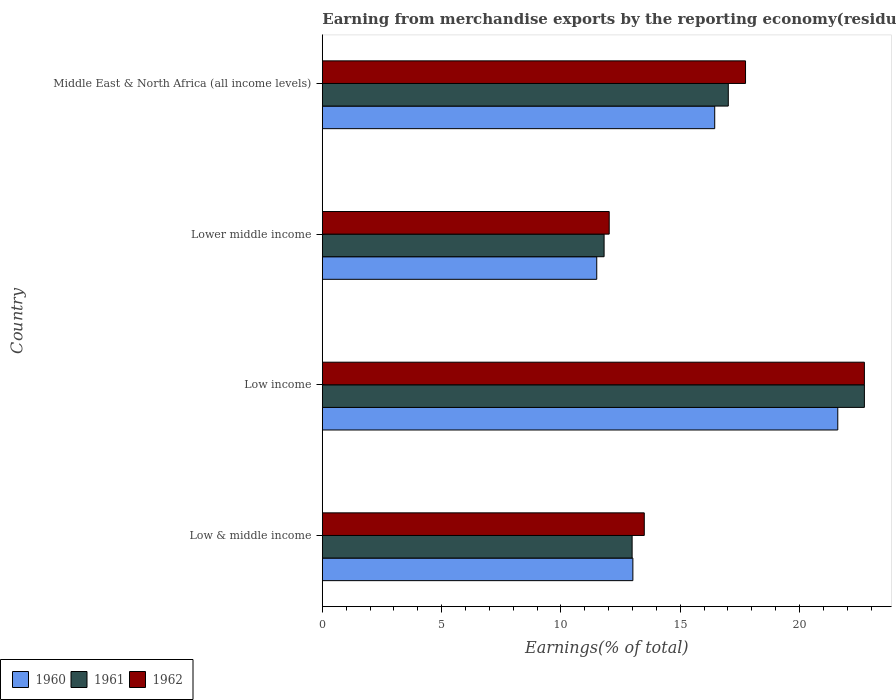How many different coloured bars are there?
Offer a terse response. 3. How many groups of bars are there?
Offer a very short reply. 4. Are the number of bars on each tick of the Y-axis equal?
Ensure brevity in your answer.  Yes. How many bars are there on the 2nd tick from the top?
Give a very brief answer. 3. How many bars are there on the 3rd tick from the bottom?
Your answer should be very brief. 3. What is the label of the 2nd group of bars from the top?
Provide a succinct answer. Lower middle income. What is the percentage of amount earned from merchandise exports in 1962 in Low income?
Provide a succinct answer. 22.72. Across all countries, what is the maximum percentage of amount earned from merchandise exports in 1960?
Make the answer very short. 21.61. Across all countries, what is the minimum percentage of amount earned from merchandise exports in 1961?
Your answer should be compact. 11.81. In which country was the percentage of amount earned from merchandise exports in 1962 maximum?
Keep it short and to the point. Low income. In which country was the percentage of amount earned from merchandise exports in 1962 minimum?
Offer a very short reply. Lower middle income. What is the total percentage of amount earned from merchandise exports in 1961 in the graph?
Offer a terse response. 64.53. What is the difference between the percentage of amount earned from merchandise exports in 1962 in Low & middle income and that in Lower middle income?
Ensure brevity in your answer.  1.47. What is the difference between the percentage of amount earned from merchandise exports in 1961 in Low & middle income and the percentage of amount earned from merchandise exports in 1960 in Middle East & North Africa (all income levels)?
Make the answer very short. -3.46. What is the average percentage of amount earned from merchandise exports in 1962 per country?
Your answer should be very brief. 16.49. What is the difference between the percentage of amount earned from merchandise exports in 1962 and percentage of amount earned from merchandise exports in 1960 in Low & middle income?
Your answer should be compact. 0.48. What is the ratio of the percentage of amount earned from merchandise exports in 1960 in Low & middle income to that in Middle East & North Africa (all income levels)?
Your answer should be very brief. 0.79. Is the difference between the percentage of amount earned from merchandise exports in 1962 in Low income and Middle East & North Africa (all income levels) greater than the difference between the percentage of amount earned from merchandise exports in 1960 in Low income and Middle East & North Africa (all income levels)?
Offer a terse response. No. What is the difference between the highest and the second highest percentage of amount earned from merchandise exports in 1961?
Keep it short and to the point. 5.7. What is the difference between the highest and the lowest percentage of amount earned from merchandise exports in 1961?
Give a very brief answer. 10.91. How many bars are there?
Your answer should be compact. 12. Are all the bars in the graph horizontal?
Make the answer very short. Yes. How many countries are there in the graph?
Provide a short and direct response. 4. What is the difference between two consecutive major ticks on the X-axis?
Ensure brevity in your answer.  5. Are the values on the major ticks of X-axis written in scientific E-notation?
Provide a succinct answer. No. Does the graph contain any zero values?
Offer a very short reply. No. Where does the legend appear in the graph?
Your answer should be very brief. Bottom left. How are the legend labels stacked?
Ensure brevity in your answer.  Horizontal. What is the title of the graph?
Your response must be concise. Earning from merchandise exports by the reporting economy(residual) of countries. Does "1997" appear as one of the legend labels in the graph?
Your response must be concise. No. What is the label or title of the X-axis?
Provide a short and direct response. Earnings(% of total). What is the Earnings(% of total) in 1960 in Low & middle income?
Provide a succinct answer. 13.02. What is the Earnings(% of total) in 1961 in Low & middle income?
Ensure brevity in your answer.  12.99. What is the Earnings(% of total) in 1962 in Low & middle income?
Provide a short and direct response. 13.49. What is the Earnings(% of total) in 1960 in Low income?
Your answer should be very brief. 21.61. What is the Earnings(% of total) in 1961 in Low income?
Give a very brief answer. 22.72. What is the Earnings(% of total) of 1962 in Low income?
Make the answer very short. 22.72. What is the Earnings(% of total) of 1960 in Lower middle income?
Keep it short and to the point. 11.5. What is the Earnings(% of total) in 1961 in Lower middle income?
Provide a succinct answer. 11.81. What is the Earnings(% of total) of 1962 in Lower middle income?
Provide a succinct answer. 12.02. What is the Earnings(% of total) of 1960 in Middle East & North Africa (all income levels)?
Offer a very short reply. 16.45. What is the Earnings(% of total) in 1961 in Middle East & North Africa (all income levels)?
Provide a succinct answer. 17.02. What is the Earnings(% of total) in 1962 in Middle East & North Africa (all income levels)?
Offer a very short reply. 17.74. Across all countries, what is the maximum Earnings(% of total) in 1960?
Your answer should be very brief. 21.61. Across all countries, what is the maximum Earnings(% of total) in 1961?
Provide a succinct answer. 22.72. Across all countries, what is the maximum Earnings(% of total) of 1962?
Make the answer very short. 22.72. Across all countries, what is the minimum Earnings(% of total) in 1960?
Your answer should be compact. 11.5. Across all countries, what is the minimum Earnings(% of total) of 1961?
Offer a terse response. 11.81. Across all countries, what is the minimum Earnings(% of total) of 1962?
Give a very brief answer. 12.02. What is the total Earnings(% of total) of 1960 in the graph?
Your answer should be compact. 62.57. What is the total Earnings(% of total) of 1961 in the graph?
Provide a succinct answer. 64.53. What is the total Earnings(% of total) of 1962 in the graph?
Your answer should be compact. 65.98. What is the difference between the Earnings(% of total) in 1960 in Low & middle income and that in Low income?
Your answer should be very brief. -8.59. What is the difference between the Earnings(% of total) in 1961 in Low & middle income and that in Low income?
Keep it short and to the point. -9.74. What is the difference between the Earnings(% of total) of 1962 in Low & middle income and that in Low income?
Offer a very short reply. -9.23. What is the difference between the Earnings(% of total) of 1960 in Low & middle income and that in Lower middle income?
Your answer should be very brief. 1.51. What is the difference between the Earnings(% of total) in 1961 in Low & middle income and that in Lower middle income?
Make the answer very short. 1.17. What is the difference between the Earnings(% of total) of 1962 in Low & middle income and that in Lower middle income?
Your response must be concise. 1.47. What is the difference between the Earnings(% of total) of 1960 in Low & middle income and that in Middle East & North Africa (all income levels)?
Your answer should be very brief. -3.43. What is the difference between the Earnings(% of total) of 1961 in Low & middle income and that in Middle East & North Africa (all income levels)?
Your response must be concise. -4.03. What is the difference between the Earnings(% of total) in 1962 in Low & middle income and that in Middle East & North Africa (all income levels)?
Ensure brevity in your answer.  -4.24. What is the difference between the Earnings(% of total) of 1960 in Low income and that in Lower middle income?
Your answer should be compact. 10.1. What is the difference between the Earnings(% of total) of 1961 in Low income and that in Lower middle income?
Your answer should be very brief. 10.91. What is the difference between the Earnings(% of total) of 1962 in Low income and that in Lower middle income?
Provide a short and direct response. 10.7. What is the difference between the Earnings(% of total) in 1960 in Low income and that in Middle East & North Africa (all income levels)?
Keep it short and to the point. 5.16. What is the difference between the Earnings(% of total) in 1961 in Low income and that in Middle East & North Africa (all income levels)?
Provide a succinct answer. 5.7. What is the difference between the Earnings(% of total) in 1962 in Low income and that in Middle East & North Africa (all income levels)?
Offer a very short reply. 4.98. What is the difference between the Earnings(% of total) of 1960 in Lower middle income and that in Middle East & North Africa (all income levels)?
Give a very brief answer. -4.94. What is the difference between the Earnings(% of total) of 1961 in Lower middle income and that in Middle East & North Africa (all income levels)?
Ensure brevity in your answer.  -5.21. What is the difference between the Earnings(% of total) in 1962 in Lower middle income and that in Middle East & North Africa (all income levels)?
Your response must be concise. -5.71. What is the difference between the Earnings(% of total) of 1960 in Low & middle income and the Earnings(% of total) of 1961 in Low income?
Provide a short and direct response. -9.7. What is the difference between the Earnings(% of total) in 1960 in Low & middle income and the Earnings(% of total) in 1962 in Low income?
Your answer should be compact. -9.7. What is the difference between the Earnings(% of total) in 1961 in Low & middle income and the Earnings(% of total) in 1962 in Low income?
Keep it short and to the point. -9.74. What is the difference between the Earnings(% of total) in 1960 in Low & middle income and the Earnings(% of total) in 1961 in Lower middle income?
Give a very brief answer. 1.21. What is the difference between the Earnings(% of total) in 1960 in Low & middle income and the Earnings(% of total) in 1962 in Lower middle income?
Provide a short and direct response. 0.99. What is the difference between the Earnings(% of total) in 1961 in Low & middle income and the Earnings(% of total) in 1962 in Lower middle income?
Keep it short and to the point. 0.96. What is the difference between the Earnings(% of total) in 1960 in Low & middle income and the Earnings(% of total) in 1961 in Middle East & North Africa (all income levels)?
Offer a very short reply. -4. What is the difference between the Earnings(% of total) of 1960 in Low & middle income and the Earnings(% of total) of 1962 in Middle East & North Africa (all income levels)?
Ensure brevity in your answer.  -4.72. What is the difference between the Earnings(% of total) in 1961 in Low & middle income and the Earnings(% of total) in 1962 in Middle East & North Africa (all income levels)?
Ensure brevity in your answer.  -4.75. What is the difference between the Earnings(% of total) in 1960 in Low income and the Earnings(% of total) in 1961 in Lower middle income?
Your answer should be very brief. 9.8. What is the difference between the Earnings(% of total) in 1960 in Low income and the Earnings(% of total) in 1962 in Lower middle income?
Offer a terse response. 9.58. What is the difference between the Earnings(% of total) in 1961 in Low income and the Earnings(% of total) in 1962 in Lower middle income?
Offer a terse response. 10.7. What is the difference between the Earnings(% of total) in 1960 in Low income and the Earnings(% of total) in 1961 in Middle East & North Africa (all income levels)?
Provide a succinct answer. 4.59. What is the difference between the Earnings(% of total) of 1960 in Low income and the Earnings(% of total) of 1962 in Middle East & North Africa (all income levels)?
Offer a terse response. 3.87. What is the difference between the Earnings(% of total) of 1961 in Low income and the Earnings(% of total) of 1962 in Middle East & North Africa (all income levels)?
Keep it short and to the point. 4.98. What is the difference between the Earnings(% of total) in 1960 in Lower middle income and the Earnings(% of total) in 1961 in Middle East & North Africa (all income levels)?
Offer a very short reply. -5.51. What is the difference between the Earnings(% of total) of 1960 in Lower middle income and the Earnings(% of total) of 1962 in Middle East & North Africa (all income levels)?
Your response must be concise. -6.24. What is the difference between the Earnings(% of total) of 1961 in Lower middle income and the Earnings(% of total) of 1962 in Middle East & North Africa (all income levels)?
Your answer should be compact. -5.93. What is the average Earnings(% of total) of 1960 per country?
Ensure brevity in your answer.  15.64. What is the average Earnings(% of total) of 1961 per country?
Offer a very short reply. 16.13. What is the average Earnings(% of total) in 1962 per country?
Give a very brief answer. 16.49. What is the difference between the Earnings(% of total) in 1960 and Earnings(% of total) in 1961 in Low & middle income?
Offer a terse response. 0.03. What is the difference between the Earnings(% of total) in 1960 and Earnings(% of total) in 1962 in Low & middle income?
Offer a terse response. -0.48. What is the difference between the Earnings(% of total) in 1961 and Earnings(% of total) in 1962 in Low & middle income?
Provide a short and direct response. -0.51. What is the difference between the Earnings(% of total) of 1960 and Earnings(% of total) of 1961 in Low income?
Offer a terse response. -1.11. What is the difference between the Earnings(% of total) of 1960 and Earnings(% of total) of 1962 in Low income?
Ensure brevity in your answer.  -1.12. What is the difference between the Earnings(% of total) in 1961 and Earnings(% of total) in 1962 in Low income?
Provide a short and direct response. -0. What is the difference between the Earnings(% of total) of 1960 and Earnings(% of total) of 1961 in Lower middle income?
Provide a short and direct response. -0.31. What is the difference between the Earnings(% of total) of 1960 and Earnings(% of total) of 1962 in Lower middle income?
Ensure brevity in your answer.  -0.52. What is the difference between the Earnings(% of total) of 1961 and Earnings(% of total) of 1962 in Lower middle income?
Ensure brevity in your answer.  -0.21. What is the difference between the Earnings(% of total) of 1960 and Earnings(% of total) of 1961 in Middle East & North Africa (all income levels)?
Offer a terse response. -0.57. What is the difference between the Earnings(% of total) in 1960 and Earnings(% of total) in 1962 in Middle East & North Africa (all income levels)?
Provide a succinct answer. -1.29. What is the difference between the Earnings(% of total) in 1961 and Earnings(% of total) in 1962 in Middle East & North Africa (all income levels)?
Give a very brief answer. -0.72. What is the ratio of the Earnings(% of total) of 1960 in Low & middle income to that in Low income?
Your answer should be very brief. 0.6. What is the ratio of the Earnings(% of total) of 1961 in Low & middle income to that in Low income?
Offer a very short reply. 0.57. What is the ratio of the Earnings(% of total) in 1962 in Low & middle income to that in Low income?
Give a very brief answer. 0.59. What is the ratio of the Earnings(% of total) of 1960 in Low & middle income to that in Lower middle income?
Provide a short and direct response. 1.13. What is the ratio of the Earnings(% of total) in 1961 in Low & middle income to that in Lower middle income?
Your answer should be compact. 1.1. What is the ratio of the Earnings(% of total) of 1962 in Low & middle income to that in Lower middle income?
Offer a terse response. 1.12. What is the ratio of the Earnings(% of total) of 1960 in Low & middle income to that in Middle East & North Africa (all income levels)?
Your answer should be very brief. 0.79. What is the ratio of the Earnings(% of total) in 1961 in Low & middle income to that in Middle East & North Africa (all income levels)?
Keep it short and to the point. 0.76. What is the ratio of the Earnings(% of total) of 1962 in Low & middle income to that in Middle East & North Africa (all income levels)?
Offer a terse response. 0.76. What is the ratio of the Earnings(% of total) in 1960 in Low income to that in Lower middle income?
Your answer should be very brief. 1.88. What is the ratio of the Earnings(% of total) of 1961 in Low income to that in Lower middle income?
Offer a very short reply. 1.92. What is the ratio of the Earnings(% of total) in 1962 in Low income to that in Lower middle income?
Your response must be concise. 1.89. What is the ratio of the Earnings(% of total) of 1960 in Low income to that in Middle East & North Africa (all income levels)?
Make the answer very short. 1.31. What is the ratio of the Earnings(% of total) of 1961 in Low income to that in Middle East & North Africa (all income levels)?
Give a very brief answer. 1.34. What is the ratio of the Earnings(% of total) of 1962 in Low income to that in Middle East & North Africa (all income levels)?
Provide a short and direct response. 1.28. What is the ratio of the Earnings(% of total) in 1960 in Lower middle income to that in Middle East & North Africa (all income levels)?
Offer a terse response. 0.7. What is the ratio of the Earnings(% of total) of 1961 in Lower middle income to that in Middle East & North Africa (all income levels)?
Offer a very short reply. 0.69. What is the ratio of the Earnings(% of total) in 1962 in Lower middle income to that in Middle East & North Africa (all income levels)?
Make the answer very short. 0.68. What is the difference between the highest and the second highest Earnings(% of total) of 1960?
Make the answer very short. 5.16. What is the difference between the highest and the second highest Earnings(% of total) in 1961?
Provide a succinct answer. 5.7. What is the difference between the highest and the second highest Earnings(% of total) in 1962?
Offer a terse response. 4.98. What is the difference between the highest and the lowest Earnings(% of total) in 1960?
Your answer should be compact. 10.1. What is the difference between the highest and the lowest Earnings(% of total) of 1961?
Your answer should be very brief. 10.91. What is the difference between the highest and the lowest Earnings(% of total) in 1962?
Provide a succinct answer. 10.7. 